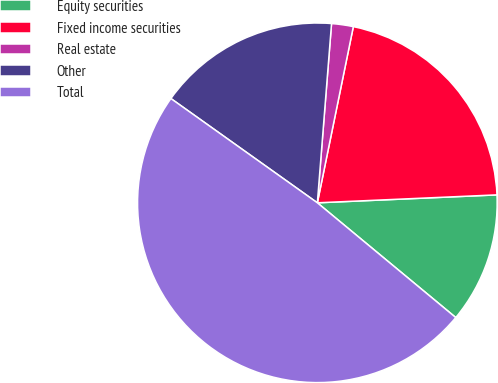Convert chart. <chart><loc_0><loc_0><loc_500><loc_500><pie_chart><fcel>Equity securities<fcel>Fixed income securities<fcel>Real estate<fcel>Other<fcel>Total<nl><fcel>11.72%<fcel>21.09%<fcel>1.95%<fcel>16.41%<fcel>48.83%<nl></chart> 